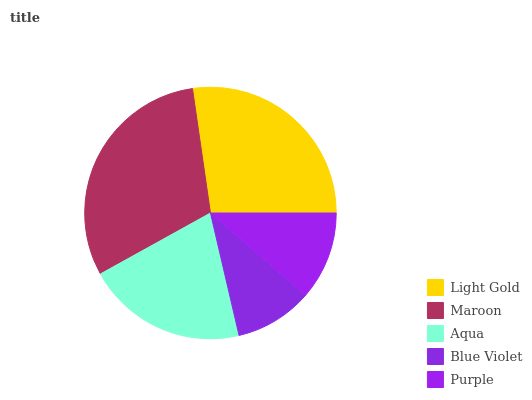Is Blue Violet the minimum?
Answer yes or no. Yes. Is Maroon the maximum?
Answer yes or no. Yes. Is Aqua the minimum?
Answer yes or no. No. Is Aqua the maximum?
Answer yes or no. No. Is Maroon greater than Aqua?
Answer yes or no. Yes. Is Aqua less than Maroon?
Answer yes or no. Yes. Is Aqua greater than Maroon?
Answer yes or no. No. Is Maroon less than Aqua?
Answer yes or no. No. Is Aqua the high median?
Answer yes or no. Yes. Is Aqua the low median?
Answer yes or no. Yes. Is Maroon the high median?
Answer yes or no. No. Is Purple the low median?
Answer yes or no. No. 